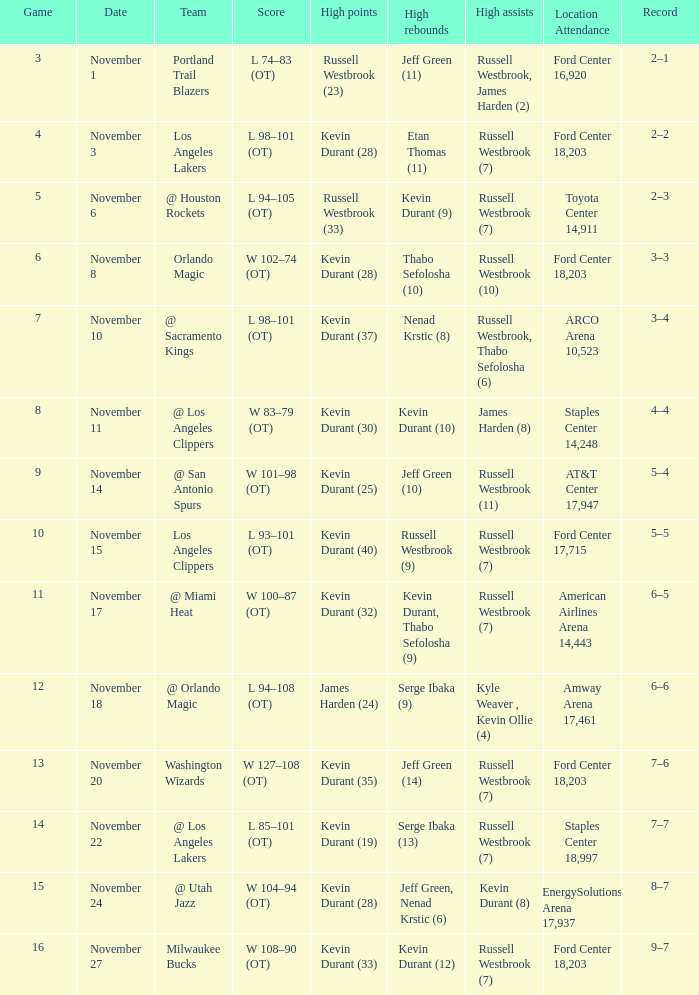When did the 3rd game occur? November 1. 